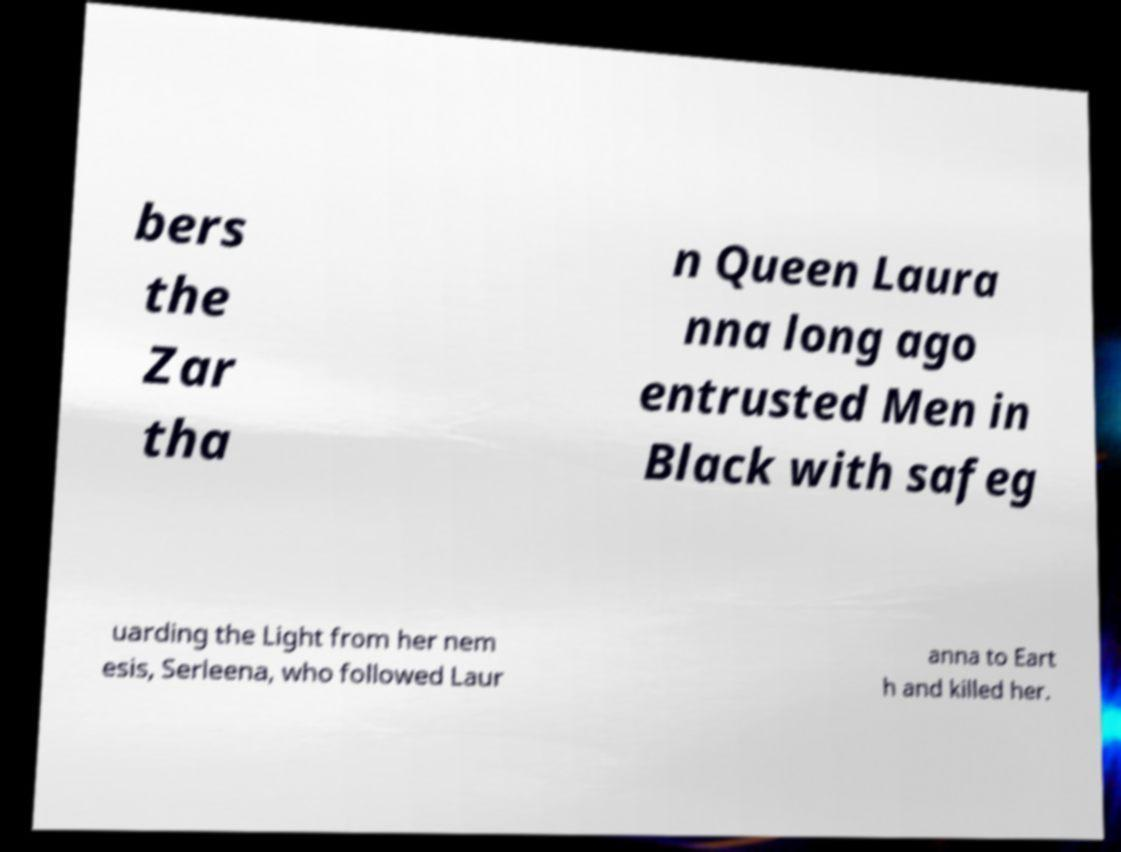I need the written content from this picture converted into text. Can you do that? bers the Zar tha n Queen Laura nna long ago entrusted Men in Black with safeg uarding the Light from her nem esis, Serleena, who followed Laur anna to Eart h and killed her. 